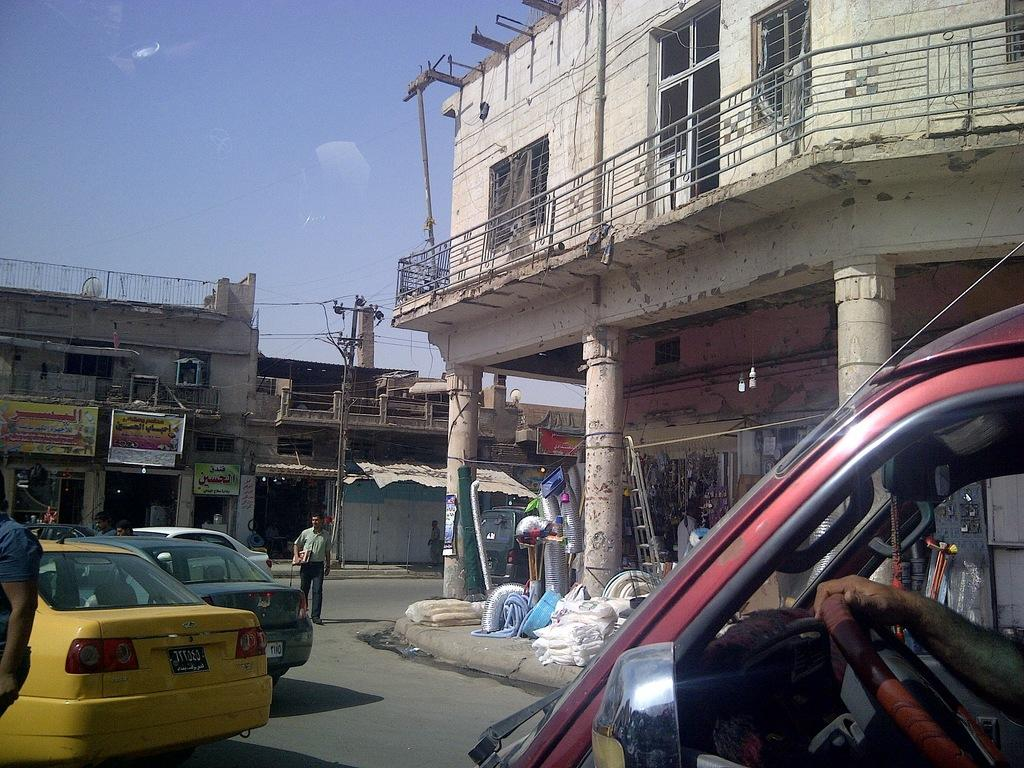What type of structures can be seen in the image? There are buildings in the image. What else is present in the image besides buildings? There are vehicles, people standing on the ground, pillars, and other objects in the image. Can you describe the vehicles in the image? The specific types of vehicles are not mentioned, but they are present in the image. What is visible in the background of the image? The sky is visible in the background of the image. Where is the plate located in the image? There is no plate present in the image. Can you tell me how many basketballs are being played with in the image? There is no basketball or any indication of a game being played in the image. Is there a baby visible in the image? There is no baby present in the image. 